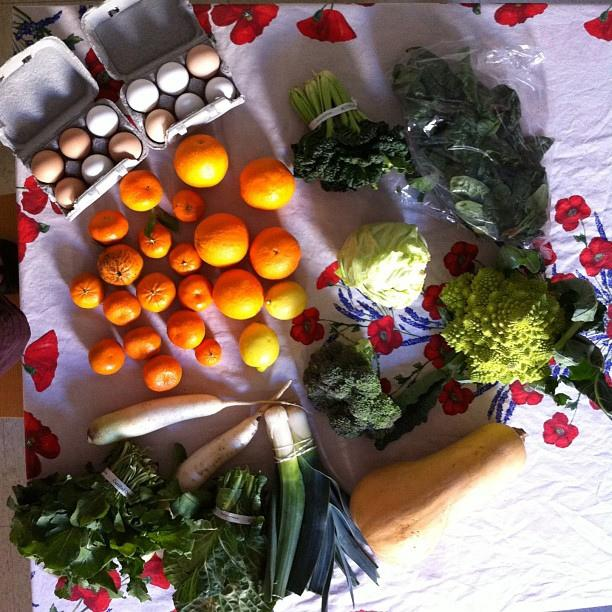Why are the eggs placed in the container? storage 